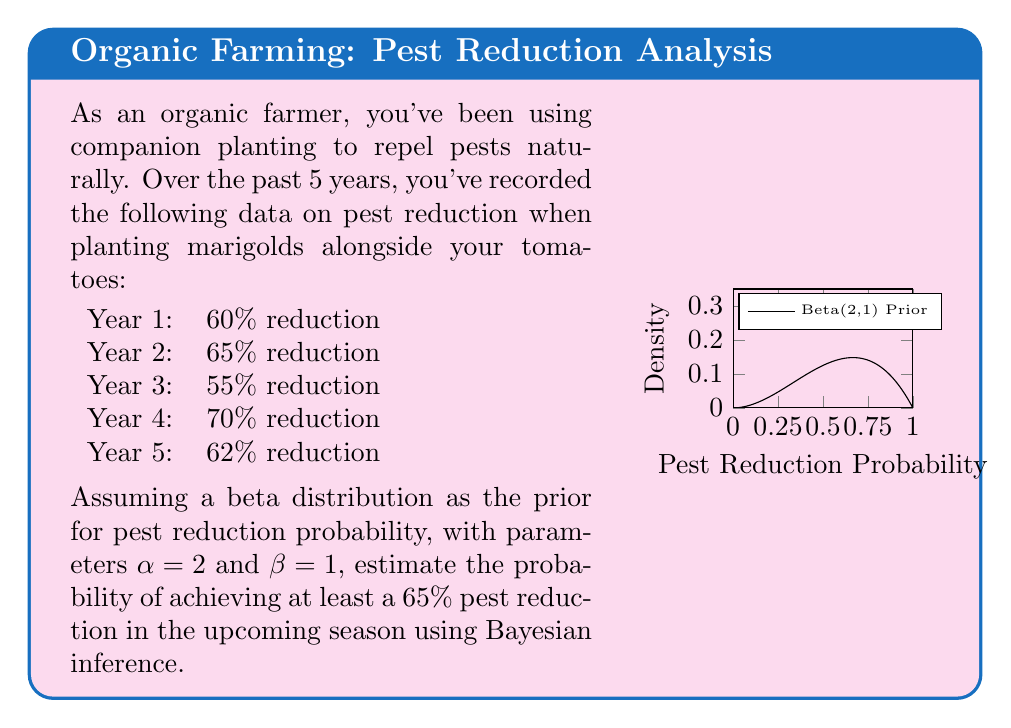Can you answer this question? To solve this problem using Bayesian inference, we'll follow these steps:

1) First, let's calculate the parameters of the posterior beta distribution:
   $\alpha_{posterior} = \alpha_{prior} + \text{number of successes}$
   $\beta_{posterior} = \beta_{prior} + \text{number of failures}$

   We consider a "success" as achieving at least 65% reduction.
   From the data: 2 years (Year 2 and Year 4) achieved ≥65% reduction.

   $\alpha_{posterior} = 2 + 2 = 4$
   $\beta_{posterior} = 1 + 3 = 4$

2) The posterior distribution is thus Beta(4,4).

3) To find the probability of achieving at least 65% reduction in the upcoming season, we need to calculate:

   $P(X \geq 0.65) = 1 - P(X < 0.65)$

   where X follows a Beta(4,4) distribution.

4) This can be calculated using the cumulative beta distribution function:

   $P(X \geq 0.65) = 1 - I_{0.65}(4,4)$

   where $I_x(a,b)$ is the regularized incomplete beta function.

5) Using a statistical calculator or software, we find:

   $I_{0.65}(4,4) \approx 0.7744$

6) Therefore:

   $P(X \geq 0.65) = 1 - 0.7744 \approx 0.2256$

Thus, based on the historical data and our prior belief, there is approximately a 22.56% chance of achieving at least a 65% pest reduction in the upcoming season.
Answer: $0.2256$ or $22.56\%$ 